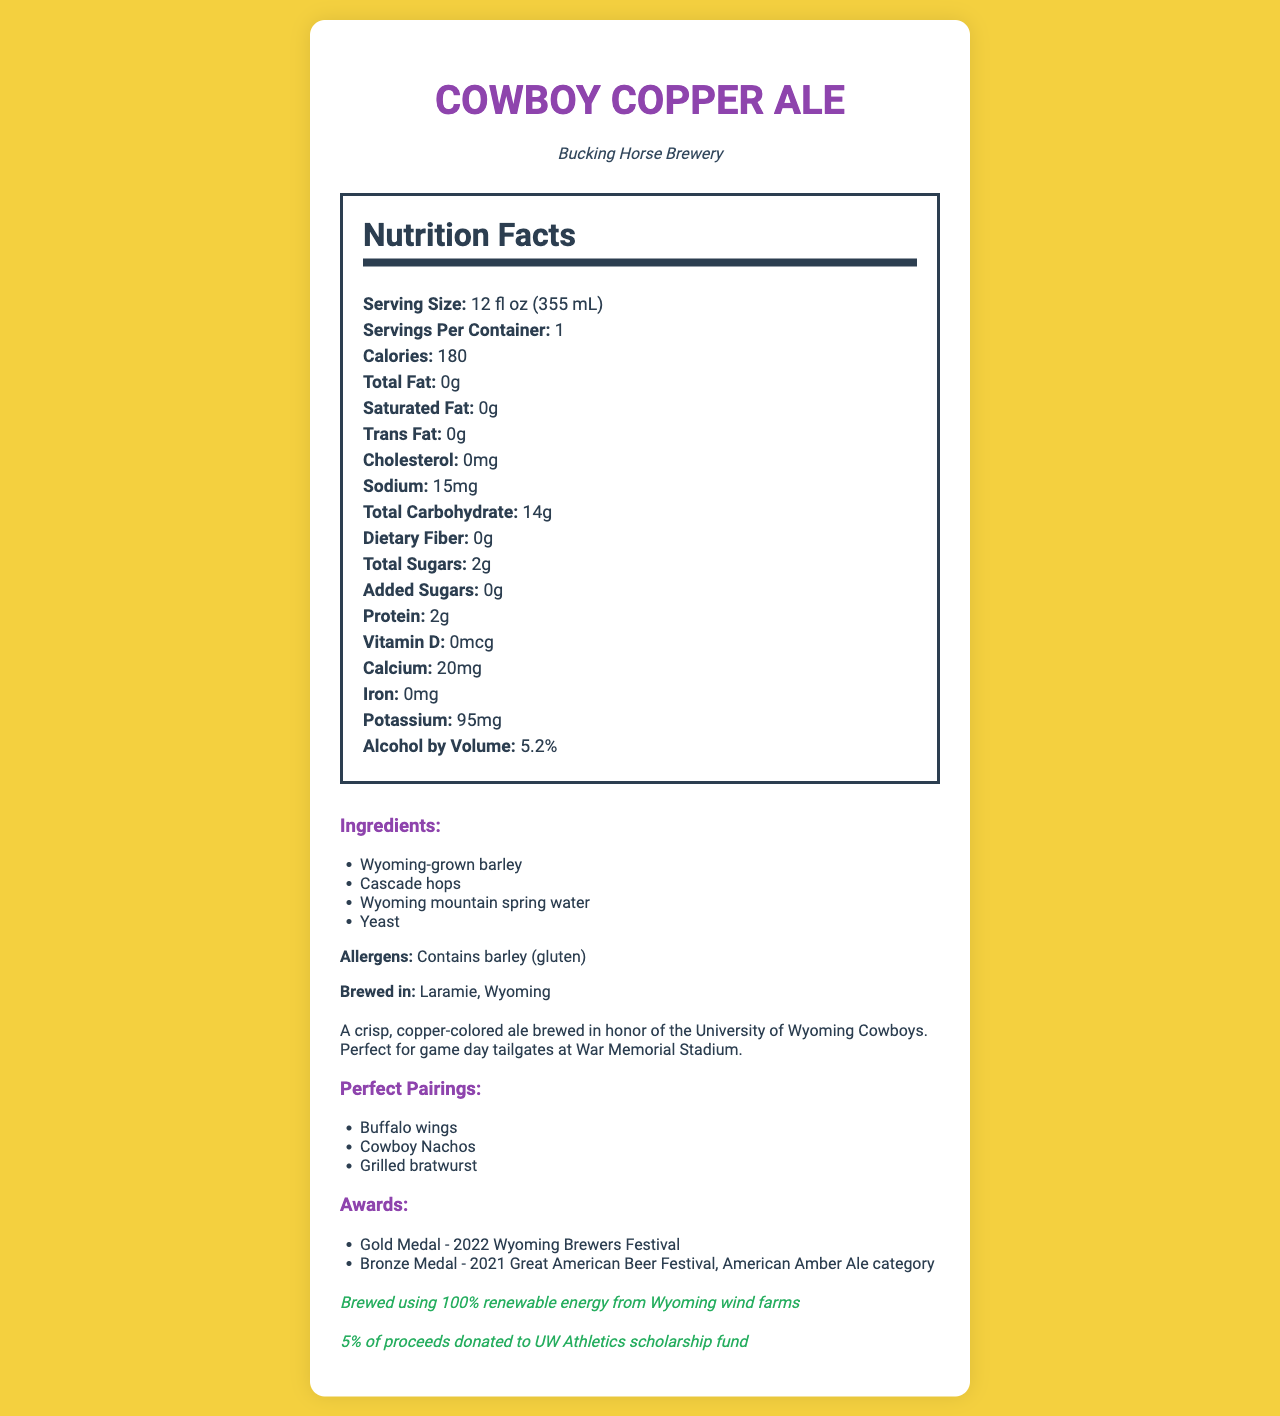what is the serving size for Cowboy Copper Ale? The serving size is listed at the top of the nutrition facts section.
Answer: 12 fl oz (355 mL) how many calories are in one serving of Cowboy Copper Ale? The calories per serving are clearly stated in the nutrition facts section.
Answer: 180 what is the sodium content per serving? The sodium content is mentioned in the nutrition facts section.
Answer: 15 mg which ingredient is grown locally in Wyoming? It is listed in the ingredients section.
Answer: Wyoming-grown barley what is the alcohol by volume (ABV) percentage? The ABV is listed at the bottom of the nutrition facts section.
Answer: 5.2% what are the allergens present in Cowboy Copper Ale? The allergens are listed in the ingredients section.
Answer: Contains barley (gluten) where is Cowboy Copper Ale brewed? The location of the brewery is mentioned in the ingredients section under "Brewed in."
Answer: Laramie, Wyoming what food pairings are suggested? A. Cheese Pizza, French Fries, Salad B. Buffalo Wings, Cowboy Nachos, Grilled Bratwurst C. Sushi, Tacos, Cheeseburgers The pairings section lists Buffalo Wings, Cowboy Nachos, and Grilled Bratwurst as perfect pairings.
Answer: B which of the following awards has Cowboy Copper Ale won? 1. Silver Medal - 2022 International Beer Challenge 2. Gold Medal - 2022 Wyoming Brewers Festival 3. Platinum Medal - 2023 World Beer Awards The awards section mentions the Gold Medal at the 2022 Wyoming Brewers Festival.
Answer: 2 does Cowboy Copper Ale contain added sugars? The nutrition facts state that there are 0 grams of added sugars.
Answer: No describe the main cause for celebration in Cowboy Copper Ale's description? The description section explains the main motivations and usage for Cowboy Copper Ale.
Answer: It is brewed in honor of the University of Wyoming Cowboys, and it is perfect for game day tailgates at War Memorial Stadium. what percentage of proceeds is donated to UW Athletics scholarship fund? The charity section at the end of the document states that 5% of proceeds are donated to the UW Athletics scholarship fund.
Answer: 5% is Cowboy Copper Ale brewed using renewable energy? The sustainability section states that the ale is brewed using 100% renewable energy from Wyoming wind farms.
Answer: Yes can we determine the exact brewing process of Cowboy Copper Ale from this document? The document provides details about ingredients and sustainability but does not detail the exact brewing process.
Answer: Not enough information 